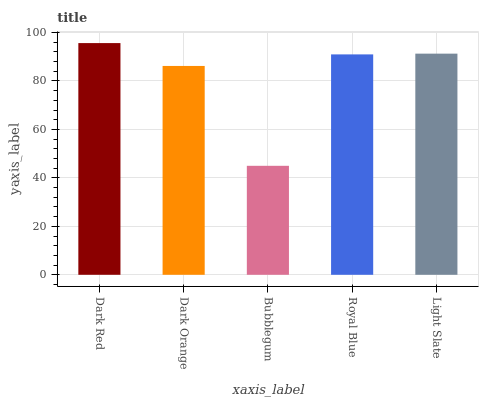Is Bubblegum the minimum?
Answer yes or no. Yes. Is Dark Red the maximum?
Answer yes or no. Yes. Is Dark Orange the minimum?
Answer yes or no. No. Is Dark Orange the maximum?
Answer yes or no. No. Is Dark Red greater than Dark Orange?
Answer yes or no. Yes. Is Dark Orange less than Dark Red?
Answer yes or no. Yes. Is Dark Orange greater than Dark Red?
Answer yes or no. No. Is Dark Red less than Dark Orange?
Answer yes or no. No. Is Royal Blue the high median?
Answer yes or no. Yes. Is Royal Blue the low median?
Answer yes or no. Yes. Is Dark Red the high median?
Answer yes or no. No. Is Bubblegum the low median?
Answer yes or no. No. 